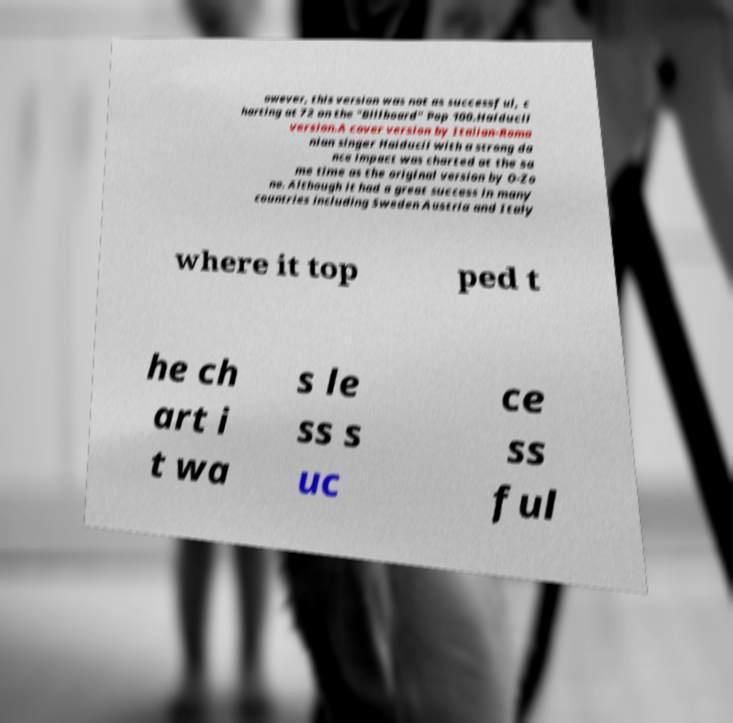I need the written content from this picture converted into text. Can you do that? owever, this version was not as successful, c harting at 72 on the "Billboard" Pop 100.Haiducii version.A cover version by Italian-Roma nian singer Haiducii with a strong da nce impact was charted at the sa me time as the original version by O-Zo ne. Although it had a great success in many countries including Sweden Austria and Italy where it top ped t he ch art i t wa s le ss s uc ce ss ful 